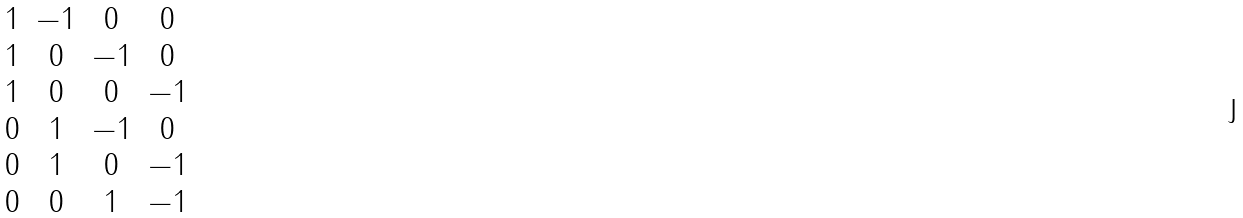Convert formula to latex. <formula><loc_0><loc_0><loc_500><loc_500>\begin{matrix} 1 & - 1 & 0 & 0 \\ 1 & 0 & - 1 & 0 \\ 1 & 0 & 0 & - 1 \\ 0 & 1 & - 1 & 0 \\ 0 & 1 & 0 & - 1 \\ 0 & 0 & 1 & - 1 \end{matrix}</formula> 